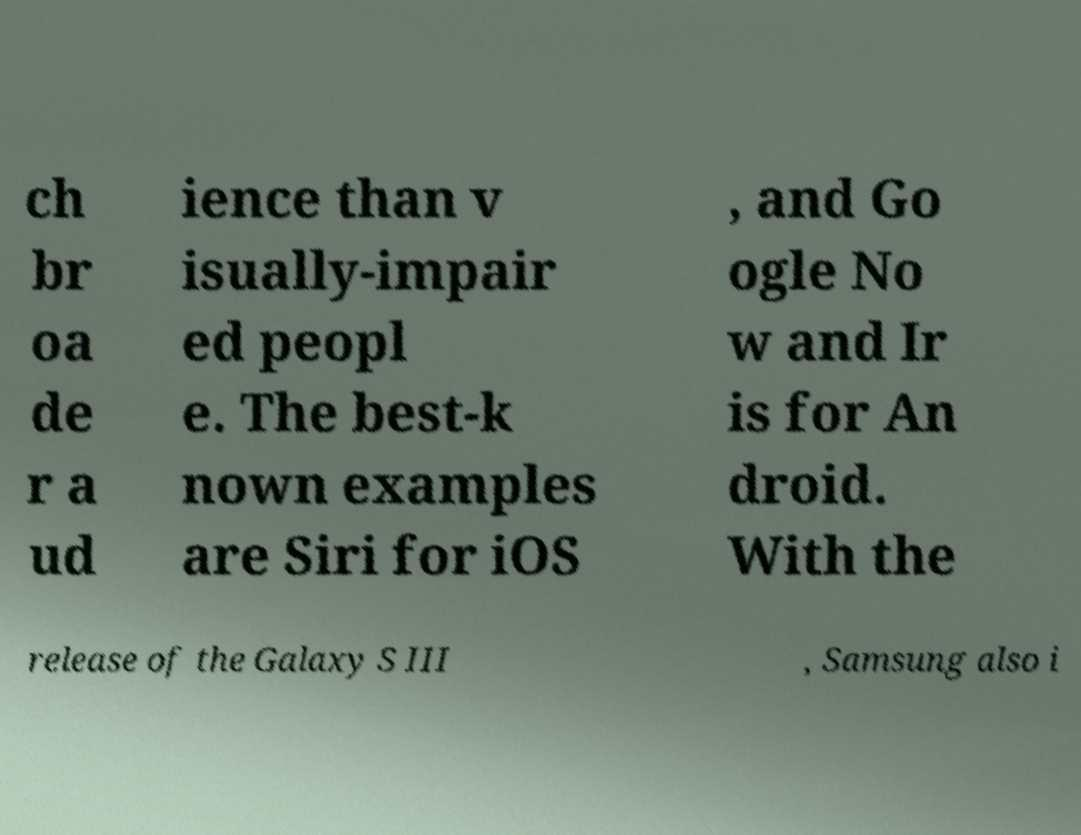Please read and relay the text visible in this image. What does it say? ch br oa de r a ud ience than v isually-impair ed peopl e. The best-k nown examples are Siri for iOS , and Go ogle No w and Ir is for An droid. With the release of the Galaxy S III , Samsung also i 